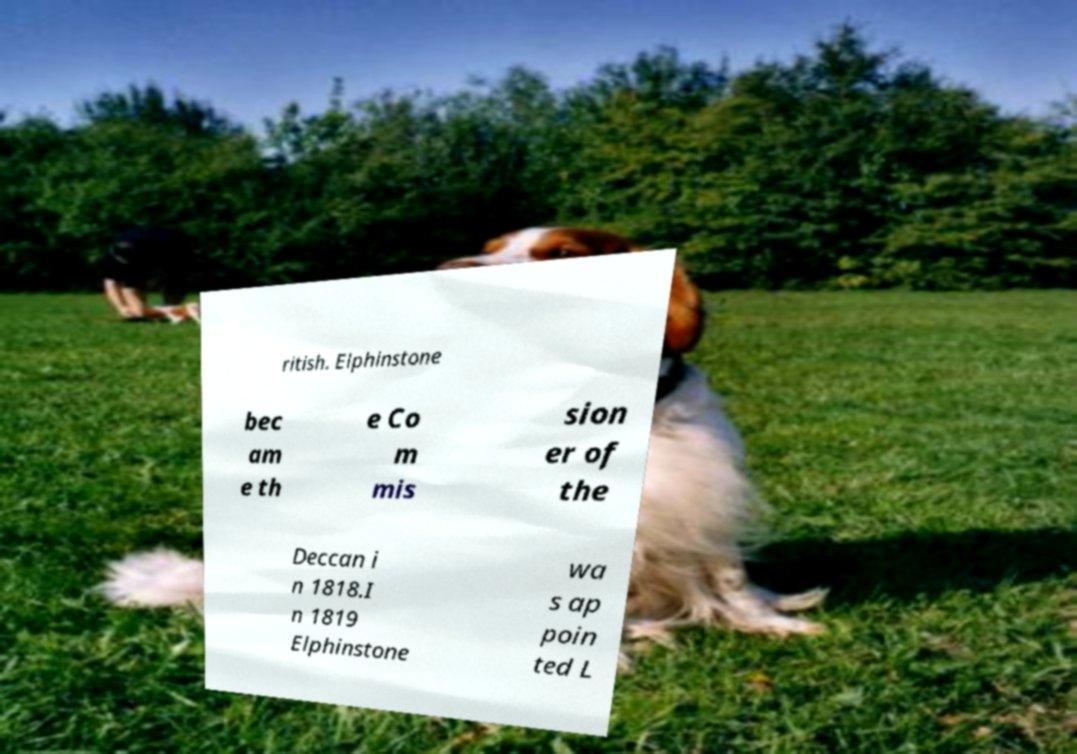Could you extract and type out the text from this image? ritish. Elphinstone bec am e th e Co m mis sion er of the Deccan i n 1818.I n 1819 Elphinstone wa s ap poin ted L 